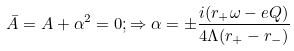Convert formula to latex. <formula><loc_0><loc_0><loc_500><loc_500>\bar { A } = A + \alpha ^ { 2 } = 0 ; \Rightarrow \alpha = \pm \frac { i ( r _ { + } \omega - e Q ) } { 4 \Lambda ( r _ { + } - r _ { - } ) }</formula> 